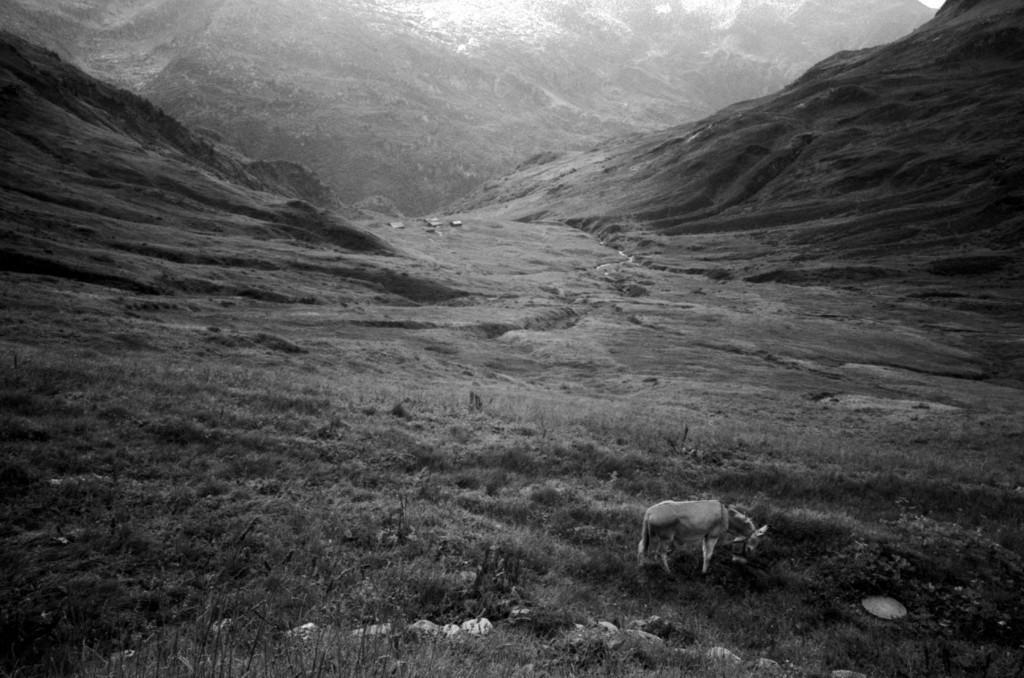How would you summarize this image in a sentence or two? In this image in the front there is an animal standing and there's grass on the ground. In the background there are mountains. 